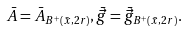Convert formula to latex. <formula><loc_0><loc_0><loc_500><loc_500>\bar { A } = \bar { A } _ { B ^ { + } ( \bar { x } , 2 r ) } , \bar { \vec { g } } = \bar { \vec { g } } _ { B ^ { + } ( \bar { x } , 2 r ) } .</formula> 